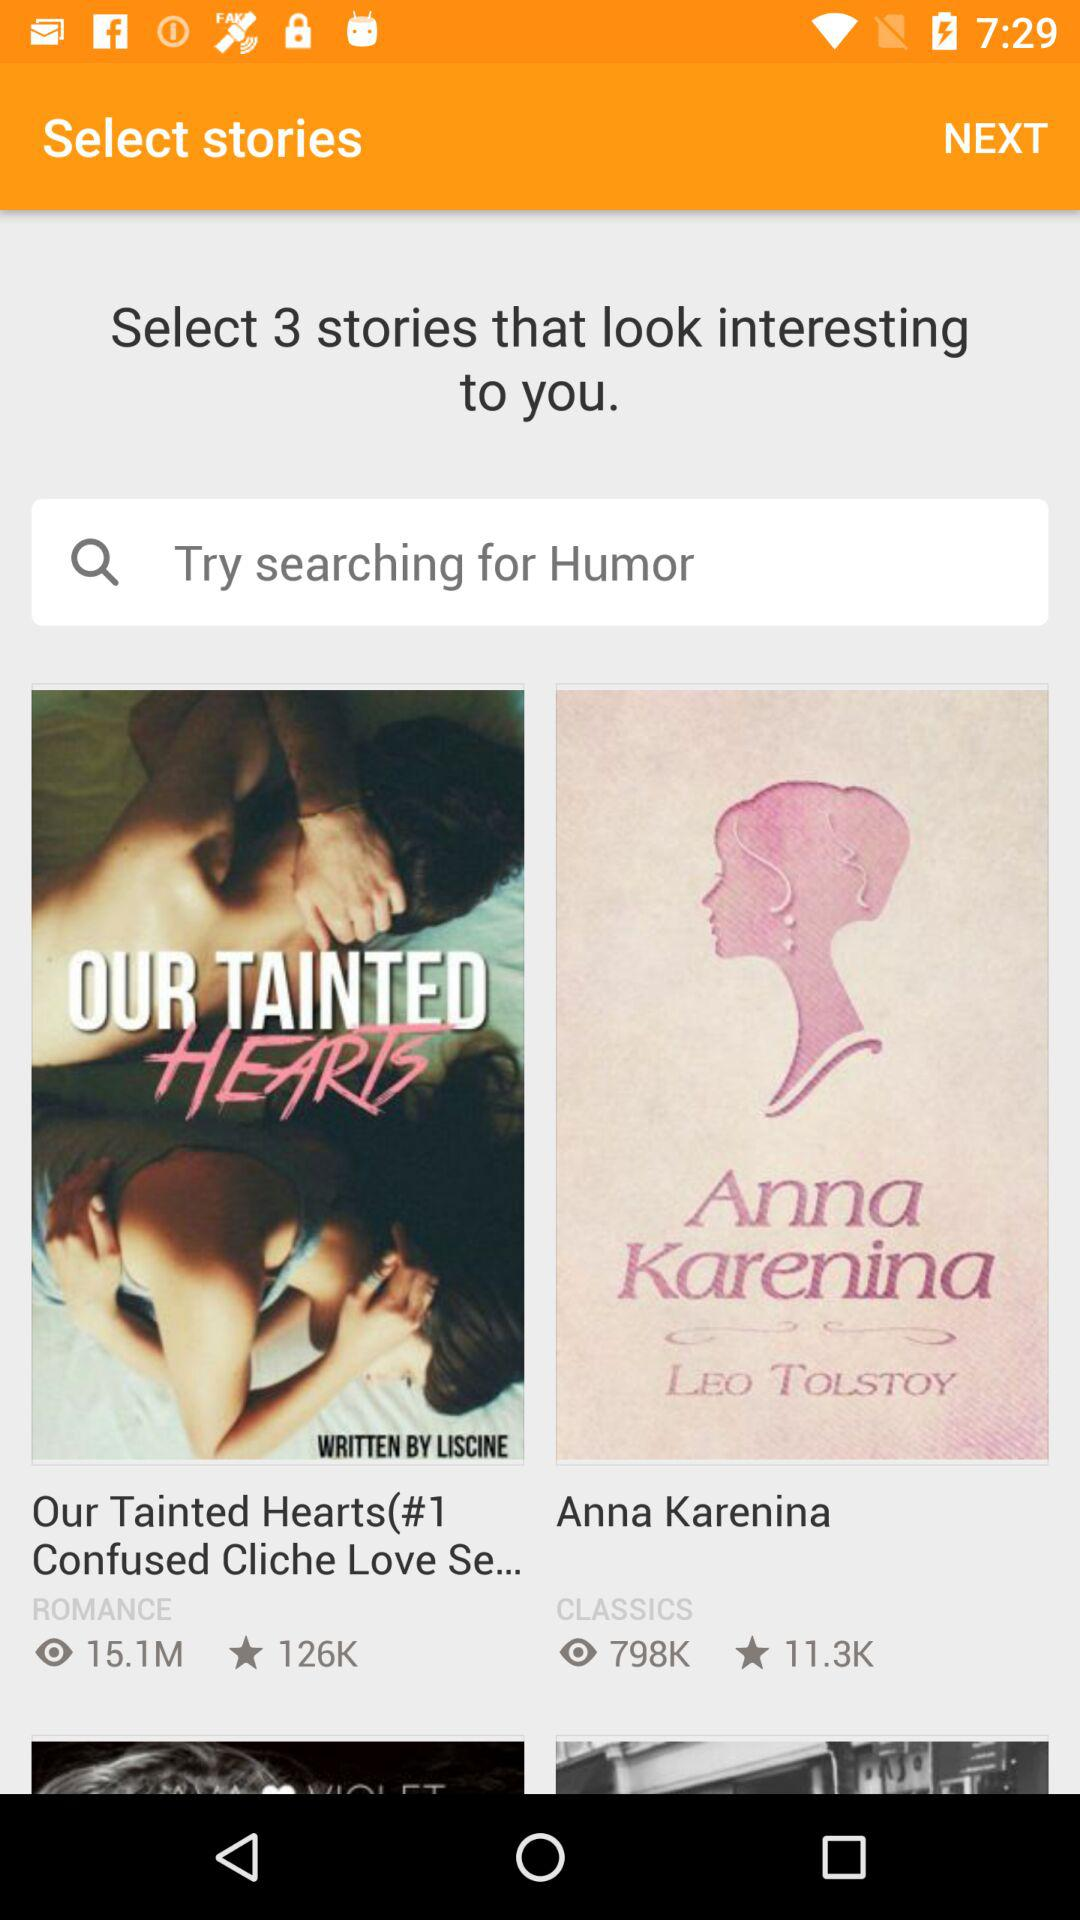How many stories are selected?
When the provided information is insufficient, respond with <no answer>. <no answer> 